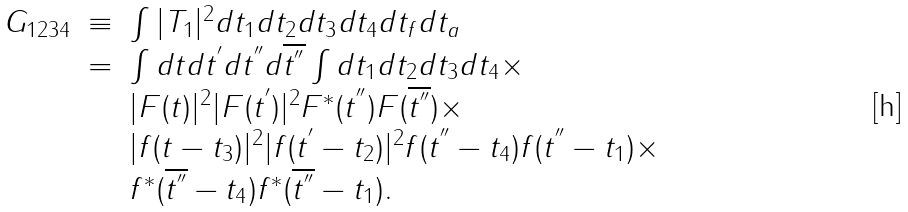Convert formula to latex. <formula><loc_0><loc_0><loc_500><loc_500>\begin{array} { l c l } G _ { 1 2 3 4 } & \equiv & \int | T _ { 1 } | ^ { 2 } d t _ { 1 } d t _ { 2 } d t _ { 3 } d t _ { 4 } d t _ { f } d t _ { a } \\ & = & \int d t d t ^ { ^ { \prime } } d t ^ { ^ { \prime \prime } } d \overline { t ^ { ^ { \prime \prime } } } \int d t _ { 1 } d t _ { 2 } d t _ { 3 } d t _ { 4 } \times \\ & & | F ( t ) | ^ { 2 } | F ( t ^ { ^ { \prime } } ) | ^ { 2 } F ^ { * } ( t ^ { ^ { \prime \prime } } ) F ( \overline { t ^ { ^ { \prime \prime } } } ) \times \\ & & | f ( t - t _ { 3 } ) | ^ { 2 } | f ( t ^ { ^ { \prime } } - t _ { 2 } ) | ^ { 2 } f ( t ^ { ^ { \prime \prime } } - t _ { 4 } ) f ( t ^ { ^ { \prime \prime } } - t _ { 1 } ) \times \\ & & f ^ { * } ( \overline { t ^ { ^ { \prime \prime } } } - t _ { 4 } ) f ^ { * } ( \overline { t ^ { ^ { \prime \prime } } } - t _ { 1 } ) . \end{array}</formula> 